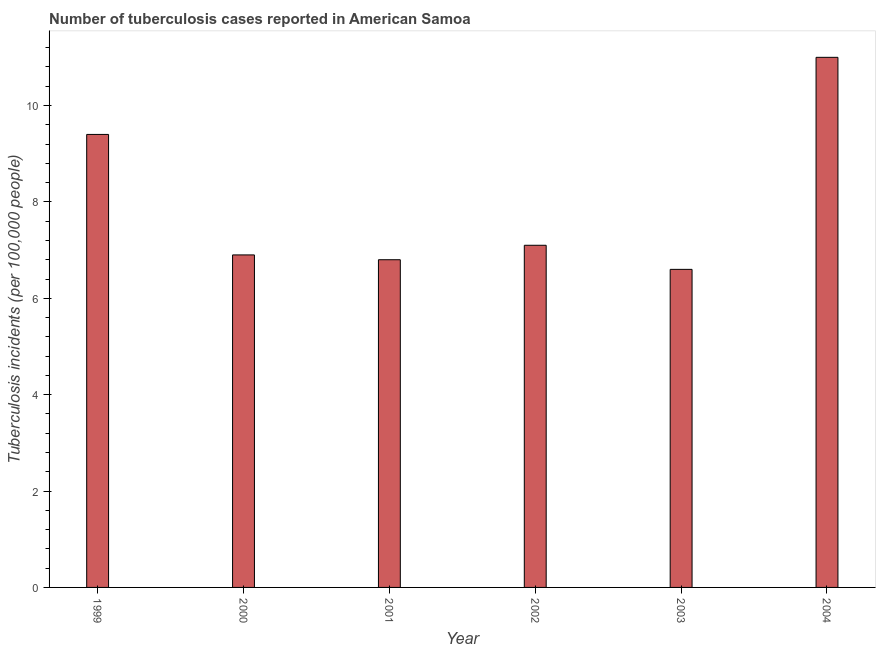Does the graph contain any zero values?
Your answer should be very brief. No. Does the graph contain grids?
Your answer should be very brief. No. What is the title of the graph?
Offer a very short reply. Number of tuberculosis cases reported in American Samoa. What is the label or title of the X-axis?
Provide a succinct answer. Year. What is the label or title of the Y-axis?
Keep it short and to the point. Tuberculosis incidents (per 100,0 people). What is the number of tuberculosis incidents in 2000?
Keep it short and to the point. 6.9. Across all years, what is the maximum number of tuberculosis incidents?
Ensure brevity in your answer.  11. In which year was the number of tuberculosis incidents maximum?
Your answer should be compact. 2004. In which year was the number of tuberculosis incidents minimum?
Your answer should be compact. 2003. What is the sum of the number of tuberculosis incidents?
Make the answer very short. 47.8. What is the average number of tuberculosis incidents per year?
Make the answer very short. 7.97. In how many years, is the number of tuberculosis incidents greater than 10.4 ?
Give a very brief answer. 1. Do a majority of the years between 2003 and 2000 (inclusive) have number of tuberculosis incidents greater than 1.2 ?
Provide a short and direct response. Yes. Is the difference between the number of tuberculosis incidents in 2001 and 2002 greater than the difference between any two years?
Ensure brevity in your answer.  No. What is the Tuberculosis incidents (per 100,000 people) of 1999?
Your answer should be compact. 9.4. What is the Tuberculosis incidents (per 100,000 people) of 2000?
Keep it short and to the point. 6.9. What is the Tuberculosis incidents (per 100,000 people) of 2001?
Your answer should be compact. 6.8. What is the difference between the Tuberculosis incidents (per 100,000 people) in 1999 and 2002?
Keep it short and to the point. 2.3. What is the difference between the Tuberculosis incidents (per 100,000 people) in 2000 and 2002?
Give a very brief answer. -0.2. What is the difference between the Tuberculosis incidents (per 100,000 people) in 2000 and 2003?
Ensure brevity in your answer.  0.3. What is the difference between the Tuberculosis incidents (per 100,000 people) in 2000 and 2004?
Offer a very short reply. -4.1. What is the difference between the Tuberculosis incidents (per 100,000 people) in 2001 and 2002?
Ensure brevity in your answer.  -0.3. What is the difference between the Tuberculosis incidents (per 100,000 people) in 2001 and 2003?
Provide a short and direct response. 0.2. What is the difference between the Tuberculosis incidents (per 100,000 people) in 2001 and 2004?
Your answer should be very brief. -4.2. What is the difference between the Tuberculosis incidents (per 100,000 people) in 2002 and 2003?
Make the answer very short. 0.5. What is the difference between the Tuberculosis incidents (per 100,000 people) in 2002 and 2004?
Make the answer very short. -3.9. What is the difference between the Tuberculosis incidents (per 100,000 people) in 2003 and 2004?
Your answer should be very brief. -4.4. What is the ratio of the Tuberculosis incidents (per 100,000 people) in 1999 to that in 2000?
Provide a short and direct response. 1.36. What is the ratio of the Tuberculosis incidents (per 100,000 people) in 1999 to that in 2001?
Provide a succinct answer. 1.38. What is the ratio of the Tuberculosis incidents (per 100,000 people) in 1999 to that in 2002?
Ensure brevity in your answer.  1.32. What is the ratio of the Tuberculosis incidents (per 100,000 people) in 1999 to that in 2003?
Offer a terse response. 1.42. What is the ratio of the Tuberculosis incidents (per 100,000 people) in 1999 to that in 2004?
Keep it short and to the point. 0.85. What is the ratio of the Tuberculosis incidents (per 100,000 people) in 2000 to that in 2001?
Keep it short and to the point. 1.01. What is the ratio of the Tuberculosis incidents (per 100,000 people) in 2000 to that in 2003?
Provide a succinct answer. 1.04. What is the ratio of the Tuberculosis incidents (per 100,000 people) in 2000 to that in 2004?
Provide a short and direct response. 0.63. What is the ratio of the Tuberculosis incidents (per 100,000 people) in 2001 to that in 2002?
Your answer should be very brief. 0.96. What is the ratio of the Tuberculosis incidents (per 100,000 people) in 2001 to that in 2004?
Your answer should be compact. 0.62. What is the ratio of the Tuberculosis incidents (per 100,000 people) in 2002 to that in 2003?
Provide a short and direct response. 1.08. What is the ratio of the Tuberculosis incidents (per 100,000 people) in 2002 to that in 2004?
Your answer should be compact. 0.65. What is the ratio of the Tuberculosis incidents (per 100,000 people) in 2003 to that in 2004?
Offer a very short reply. 0.6. 